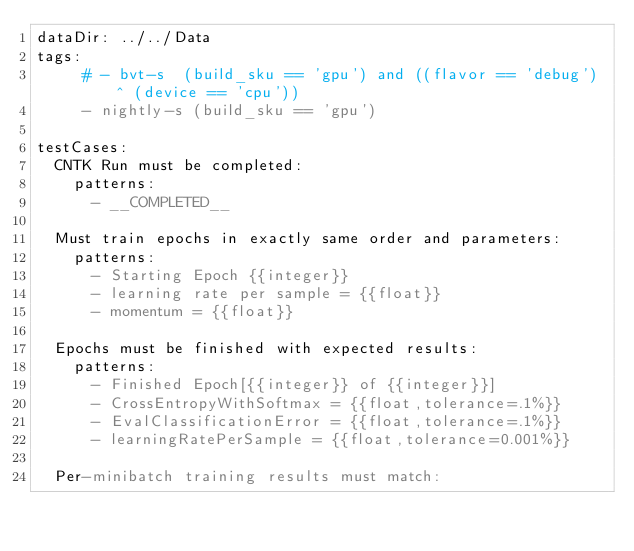Convert code to text. <code><loc_0><loc_0><loc_500><loc_500><_YAML_>dataDir: ../../Data
tags:
     # - bvt-s  (build_sku == 'gpu') and ((flavor == 'debug') ^ (device == 'cpu'))
     - nightly-s (build_sku == 'gpu')

testCases:
  CNTK Run must be completed:
    patterns:
      - __COMPLETED__

  Must train epochs in exactly same order and parameters:
    patterns:
      - Starting Epoch {{integer}}
      - learning rate per sample = {{float}}
      - momentum = {{float}}

  Epochs must be finished with expected results:
    patterns:
      - Finished Epoch[{{integer}} of {{integer}}]
      - CrossEntropyWithSoftmax = {{float,tolerance=.1%}}
      - EvalClassificationError = {{float,tolerance=.1%}}
      - learningRatePerSample = {{float,tolerance=0.001%}}

  Per-minibatch training results must match:</code> 